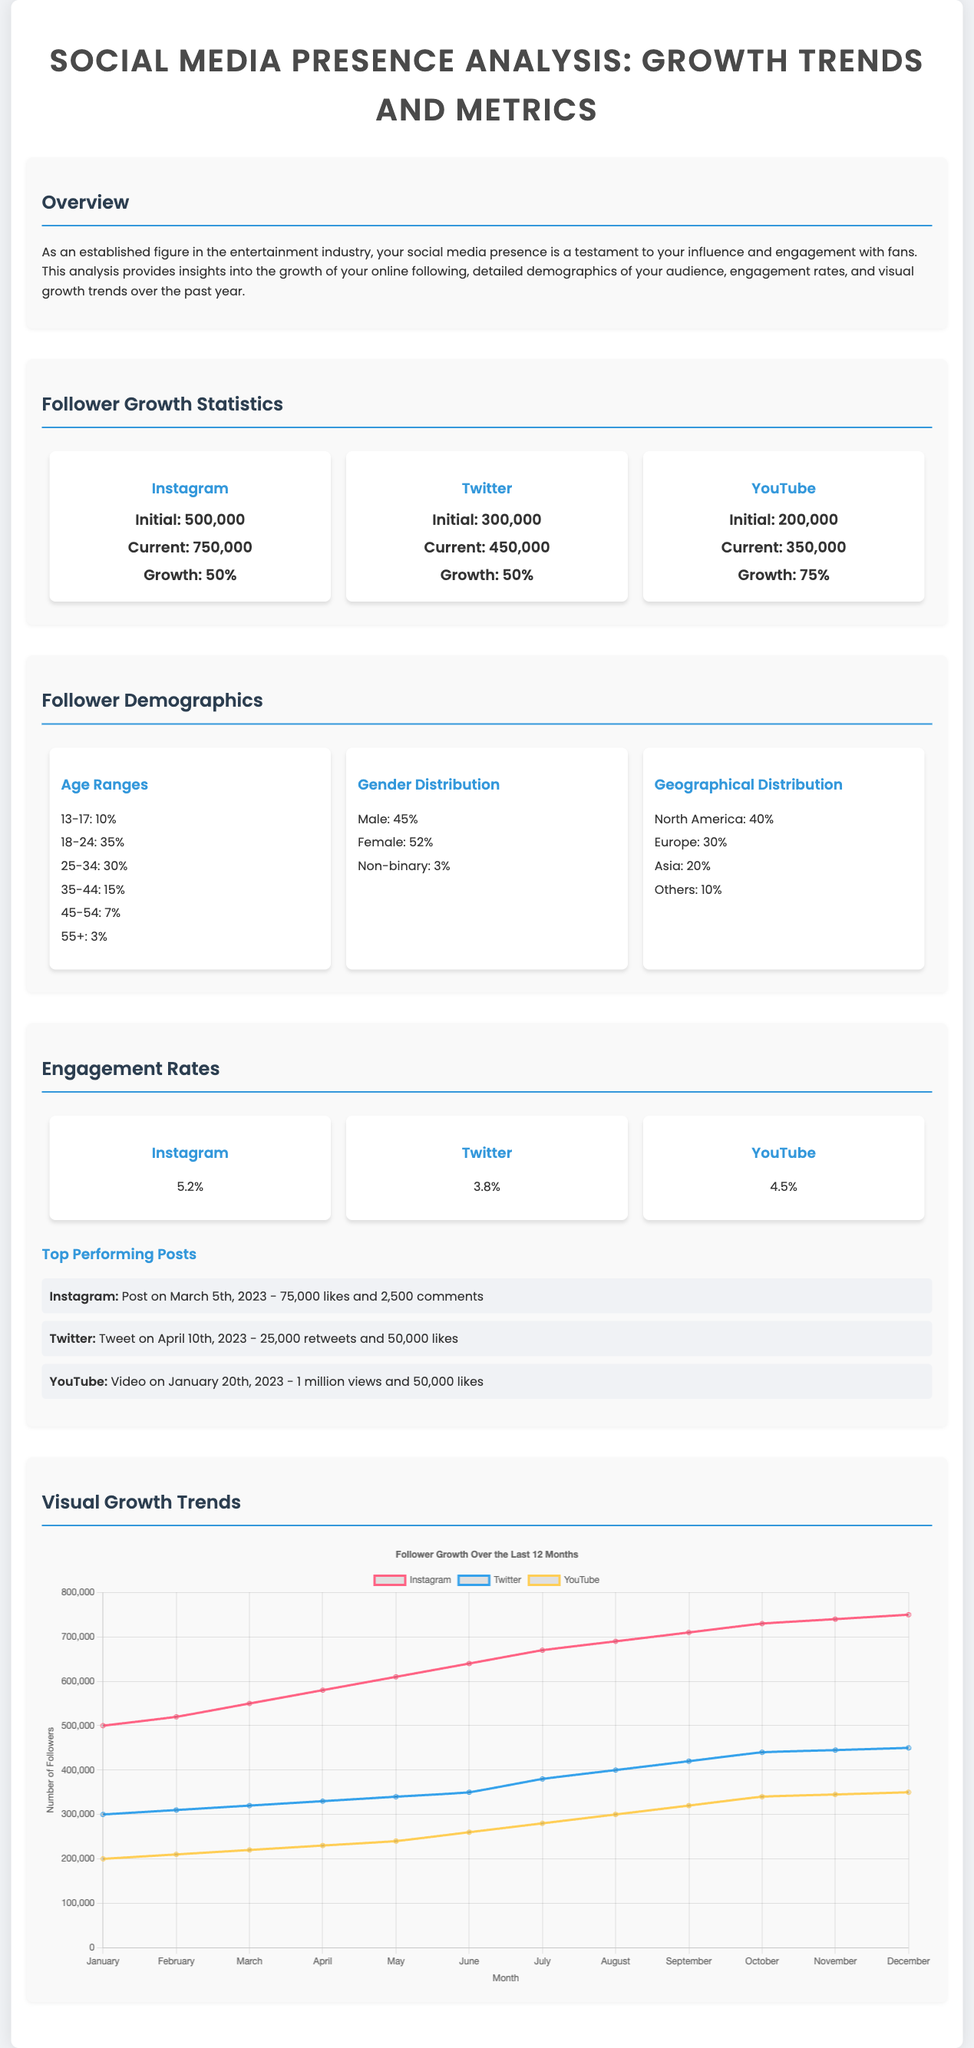What is the growth percentage of Instagram followers? The growth percentage of Instagram followers is displayed under the Instagram statistics section as 'Growth: 50%'.
Answer: 50% What is the current number of YouTube followers? The current number of YouTube followers can be found in the Follower Growth Statistics section as 'Current: 350,000'.
Answer: 350,000 What percentage of your audience is aged 18-24? The percentage of your audience aged 18-24 is provided in the Follower Demographics section as '35%'.
Answer: 35% Which platform has the highest engagement rate? The engagement rates for each platform are listed, and Instagram has the highest engagement rate at '5.2%'.
Answer: 5.2% How many followers were there on Twitter initially? The initial number of Twitter followers is shown in the statistics as 'Initial: 300,000'.
Answer: 300,000 What is the geographical distribution percentage of your followers in North America? The geographical distribution section indicates that North America accounts for '40%'.
Answer: 40% Which month had the highest Instagram followers according to the chart? By analyzing the growth chart, the highest number of Instagram followers is observed in December at '750,000'.
Answer: 750,000 What was the highest number of views reached by a YouTube post? The highest number of views for a YouTube post is mentioned as '1 million views' on the date of January 20th, 2023.
Answer: 1 million views What is the total percentage of female followers? The total percentage of female followers is provided under gender distribution as '52%'.
Answer: 52% 